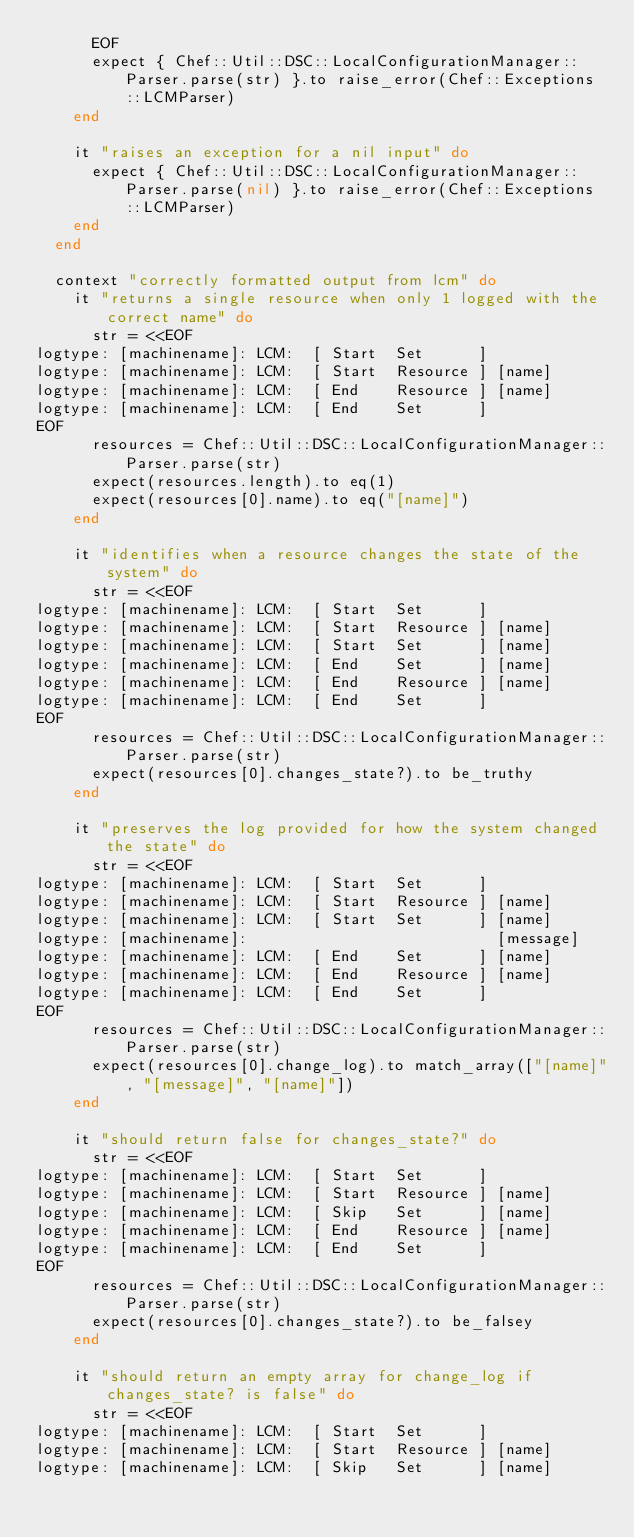<code> <loc_0><loc_0><loc_500><loc_500><_Ruby_>      EOF
      expect { Chef::Util::DSC::LocalConfigurationManager::Parser.parse(str) }.to raise_error(Chef::Exceptions::LCMParser)
    end

    it "raises an exception for a nil input" do
      expect { Chef::Util::DSC::LocalConfigurationManager::Parser.parse(nil) }.to raise_error(Chef::Exceptions::LCMParser)
    end
  end

  context "correctly formatted output from lcm" do
    it "returns a single resource when only 1 logged with the correct name" do
      str = <<EOF
logtype: [machinename]: LCM:  [ Start  Set      ]
logtype: [machinename]: LCM:  [ Start  Resource ] [name]
logtype: [machinename]: LCM:  [ End    Resource ] [name]
logtype: [machinename]: LCM:  [ End    Set      ]
EOF
      resources = Chef::Util::DSC::LocalConfigurationManager::Parser.parse(str)
      expect(resources.length).to eq(1)
      expect(resources[0].name).to eq("[name]")
    end

    it "identifies when a resource changes the state of the system" do
      str = <<EOF
logtype: [machinename]: LCM:  [ Start  Set      ]
logtype: [machinename]: LCM:  [ Start  Resource ] [name]
logtype: [machinename]: LCM:  [ Start  Set      ] [name]
logtype: [machinename]: LCM:  [ End    Set      ] [name]
logtype: [machinename]: LCM:  [ End    Resource ] [name]
logtype: [machinename]: LCM:  [ End    Set      ]
EOF
      resources = Chef::Util::DSC::LocalConfigurationManager::Parser.parse(str)
      expect(resources[0].changes_state?).to be_truthy
    end

    it "preserves the log provided for how the system changed the state" do
      str = <<EOF
logtype: [machinename]: LCM:  [ Start  Set      ]
logtype: [machinename]: LCM:  [ Start  Resource ] [name]
logtype: [machinename]: LCM:  [ Start  Set      ] [name]
logtype: [machinename]:                           [message]
logtype: [machinename]: LCM:  [ End    Set      ] [name]
logtype: [machinename]: LCM:  [ End    Resource ] [name]
logtype: [machinename]: LCM:  [ End    Set      ]
EOF
      resources = Chef::Util::DSC::LocalConfigurationManager::Parser.parse(str)
      expect(resources[0].change_log).to match_array(["[name]", "[message]", "[name]"])
    end

    it "should return false for changes_state?" do
      str = <<EOF
logtype: [machinename]: LCM:  [ Start  Set      ]
logtype: [machinename]: LCM:  [ Start  Resource ] [name]
logtype: [machinename]: LCM:  [ Skip   Set      ] [name]
logtype: [machinename]: LCM:  [ End    Resource ] [name]
logtype: [machinename]: LCM:  [ End    Set      ]
EOF
      resources = Chef::Util::DSC::LocalConfigurationManager::Parser.parse(str)
      expect(resources[0].changes_state?).to be_falsey
    end

    it "should return an empty array for change_log if changes_state? is false" do
      str = <<EOF
logtype: [machinename]: LCM:  [ Start  Set      ]
logtype: [machinename]: LCM:  [ Start  Resource ] [name]
logtype: [machinename]: LCM:  [ Skip   Set      ] [name]</code> 